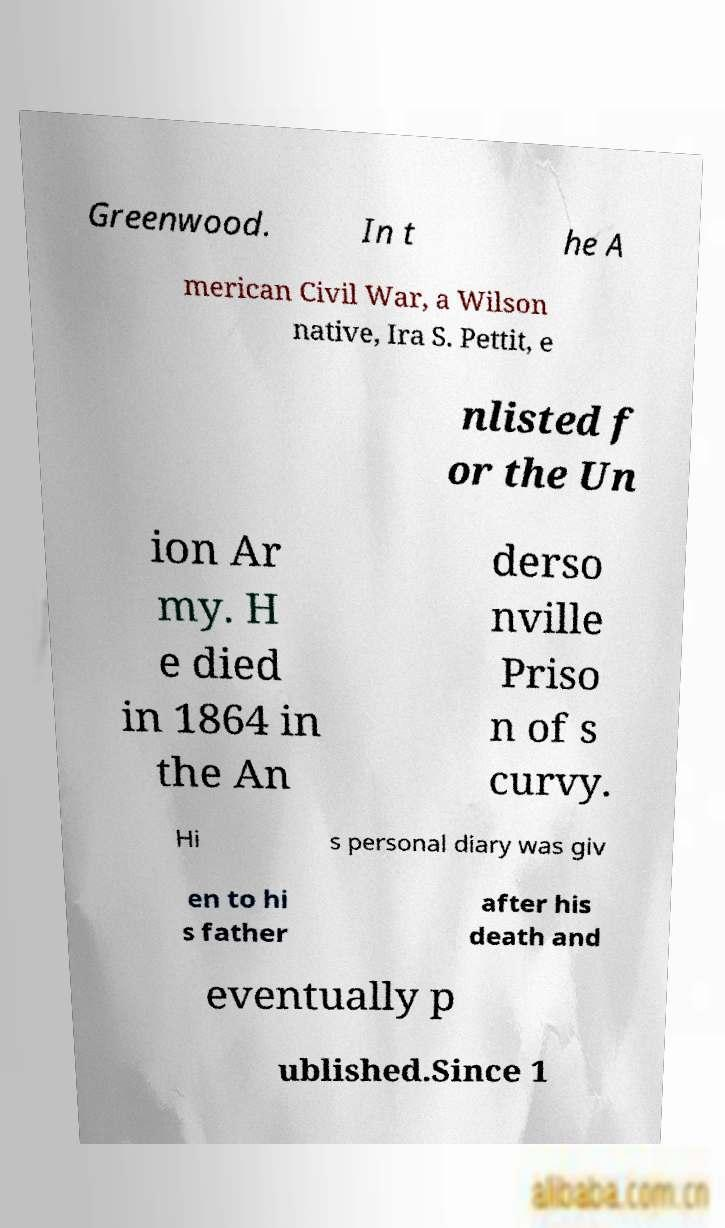What messages or text are displayed in this image? I need them in a readable, typed format. Greenwood. In t he A merican Civil War, a Wilson native, Ira S. Pettit, e nlisted f or the Un ion Ar my. H e died in 1864 in the An derso nville Priso n of s curvy. Hi s personal diary was giv en to hi s father after his death and eventually p ublished.Since 1 